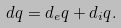<formula> <loc_0><loc_0><loc_500><loc_500>d q = d _ { e } q + d _ { i } q .</formula> 